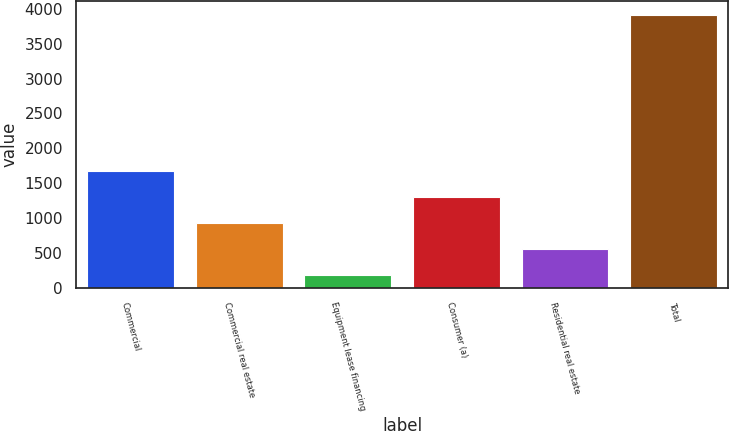<chart> <loc_0><loc_0><loc_500><loc_500><bar_chart><fcel>Commercial<fcel>Commercial real estate<fcel>Equipment lease financing<fcel>Consumer (a)<fcel>Residential real estate<fcel>Total<nl><fcel>1674.2<fcel>926.6<fcel>179<fcel>1300.4<fcel>552.8<fcel>3917<nl></chart> 